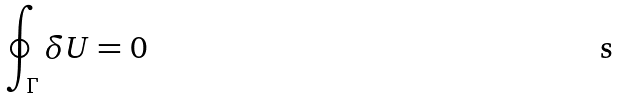<formula> <loc_0><loc_0><loc_500><loc_500>\oint _ { \Gamma } \delta U = 0</formula> 